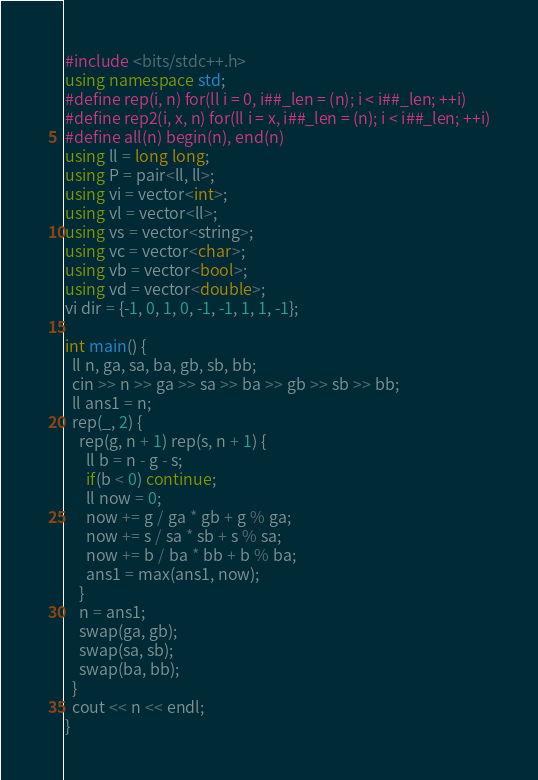Convert code to text. <code><loc_0><loc_0><loc_500><loc_500><_C++_>#include <bits/stdc++.h>
using namespace std;
#define rep(i, n) for(ll i = 0, i##_len = (n); i < i##_len; ++i)
#define rep2(i, x, n) for(ll i = x, i##_len = (n); i < i##_len; ++i)
#define all(n) begin(n), end(n)
using ll = long long;
using P = pair<ll, ll>;
using vi = vector<int>;
using vl = vector<ll>;
using vs = vector<string>;
using vc = vector<char>;
using vb = vector<bool>;
using vd = vector<double>;
vi dir = {-1, 0, 1, 0, -1, -1, 1, 1, -1};

int main() {
  ll n, ga, sa, ba, gb, sb, bb;
  cin >> n >> ga >> sa >> ba >> gb >> sb >> bb;
  ll ans1 = n;
  rep(_, 2) {
    rep(g, n + 1) rep(s, n + 1) {
      ll b = n - g - s;
      if(b < 0) continue;
      ll now = 0;
      now += g / ga * gb + g % ga;
      now += s / sa * sb + s % sa;
      now += b / ba * bb + b % ba;
      ans1 = max(ans1, now);
    }
    n = ans1;
    swap(ga, gb);
    swap(sa, sb);
    swap(ba, bb);
  }
  cout << n << endl;
}</code> 